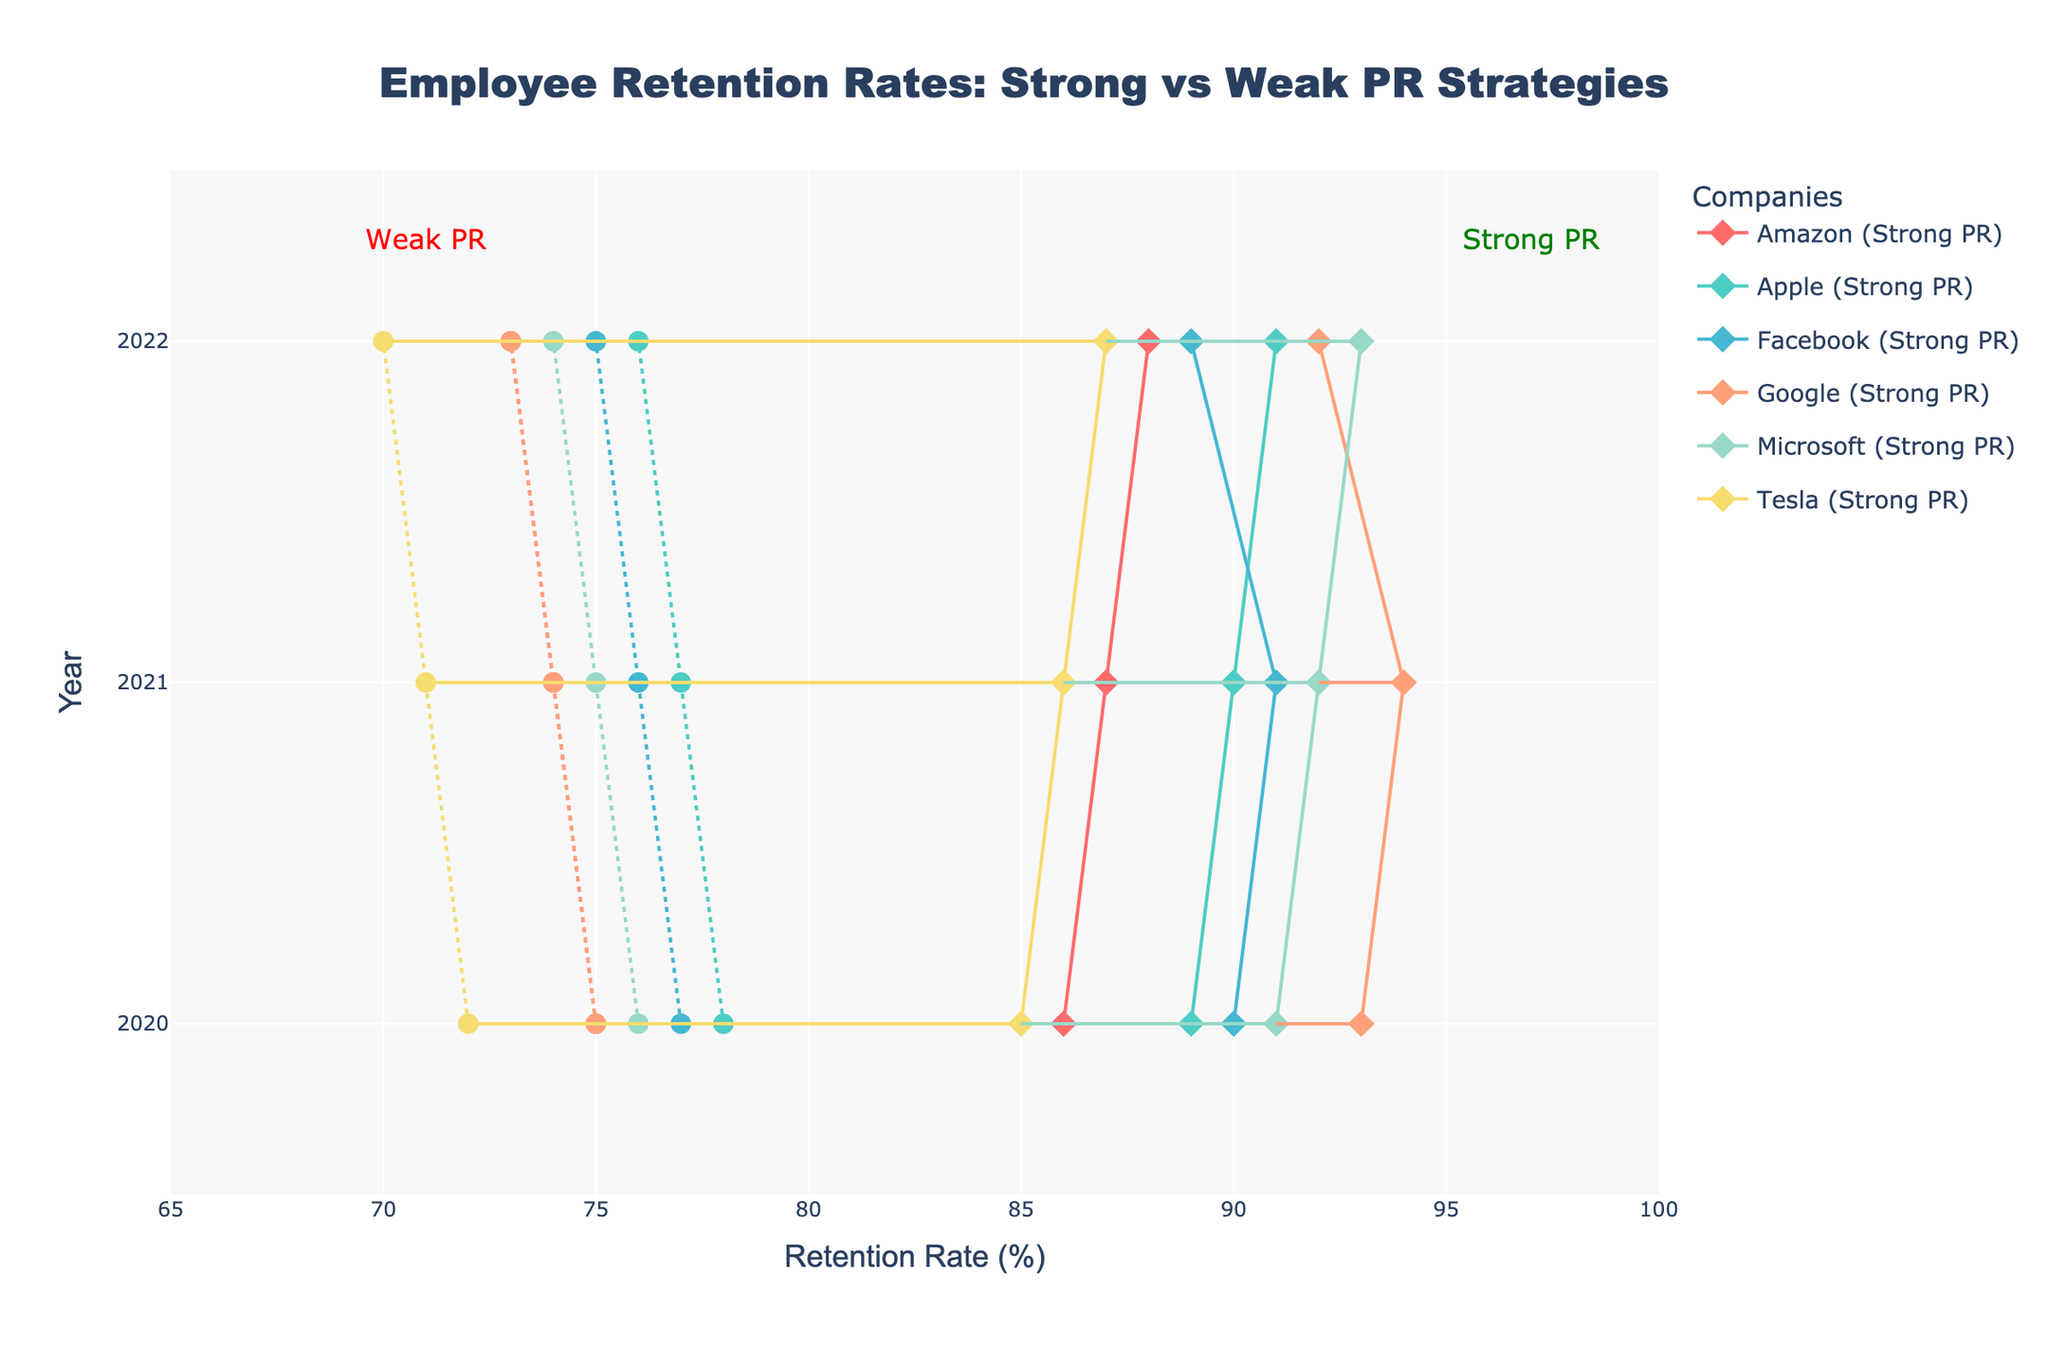How many companies are included in the employee retention rates data? The plot shows different colors for each company and there are labels for each, which indicate the number of companies included in the data.
Answer: 6 For which company and year is the retention rate for weak PR at its lowest? Look at the dumbbell positions along the x-axis for each company and year; the lowest position of a circle marker represents the weakest PR retention rate.
Answer: Tesla, 2022 What is the average retention rate difference between strong and weak PR strategies for Google over the three years shown? Calculate the difference for each year (2020, 2021, 2022) and then find the average of these differences: (93-75), (94-74), (92-73), sum them up and divide by 3: (18+20+19)/3
Answer: 19 Which company shows the smallest difference in retention rates between strong and weak PR in 2022? For 2022, find the company with the smallest horizontal line (smallest difference between diamond and circle markers in x-axis values).
Answer: Apple Among the companies listed, whose retention rate under strong PR strategy consistently improved each year? Examine each company's diamond markers along the y-axis (years 2020, 2021, 2022) to see which company's strong PR retention rate consistently increased.
Answer: Microsoft What is the overall trend observed for the retention rates for companies with weak PR strategies from 2020 to 2022? Observe the general direction the circle markers move over the years 2020 to 2022 for weak PR strategies.
Answer: Decreasing trend Which year has the largest average retention rate difference between strong and weak PR strategies across all companies? Calculate the yearly retention rate differences for all companies and find the average for each year, then identify the year with the highest average. Compute (93-75), (91-76), ..., sum these for 2020, 2021, 2022 and compare.
Answer: 2021 For which company is the benefit of having a strong PR strategy most consistent? Look at the distance between diamond and circle markers for each company and year; the company with the least variance in distances across the years is the most consistent.
Answer: Google How does Microsoft's retention rate with strong PR strategy in 2022 compare to Apple’s retention rate with weak PR strategy in the same year? Compare the x-axis value of Microsoft’s diamond marker in 2022 with Apple’s circle marker in 2022.
Answer: Higher 